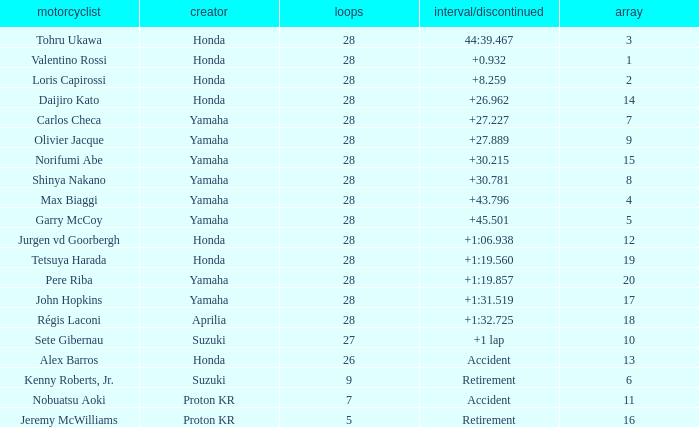Who manufactured grid 11? Proton KR. 